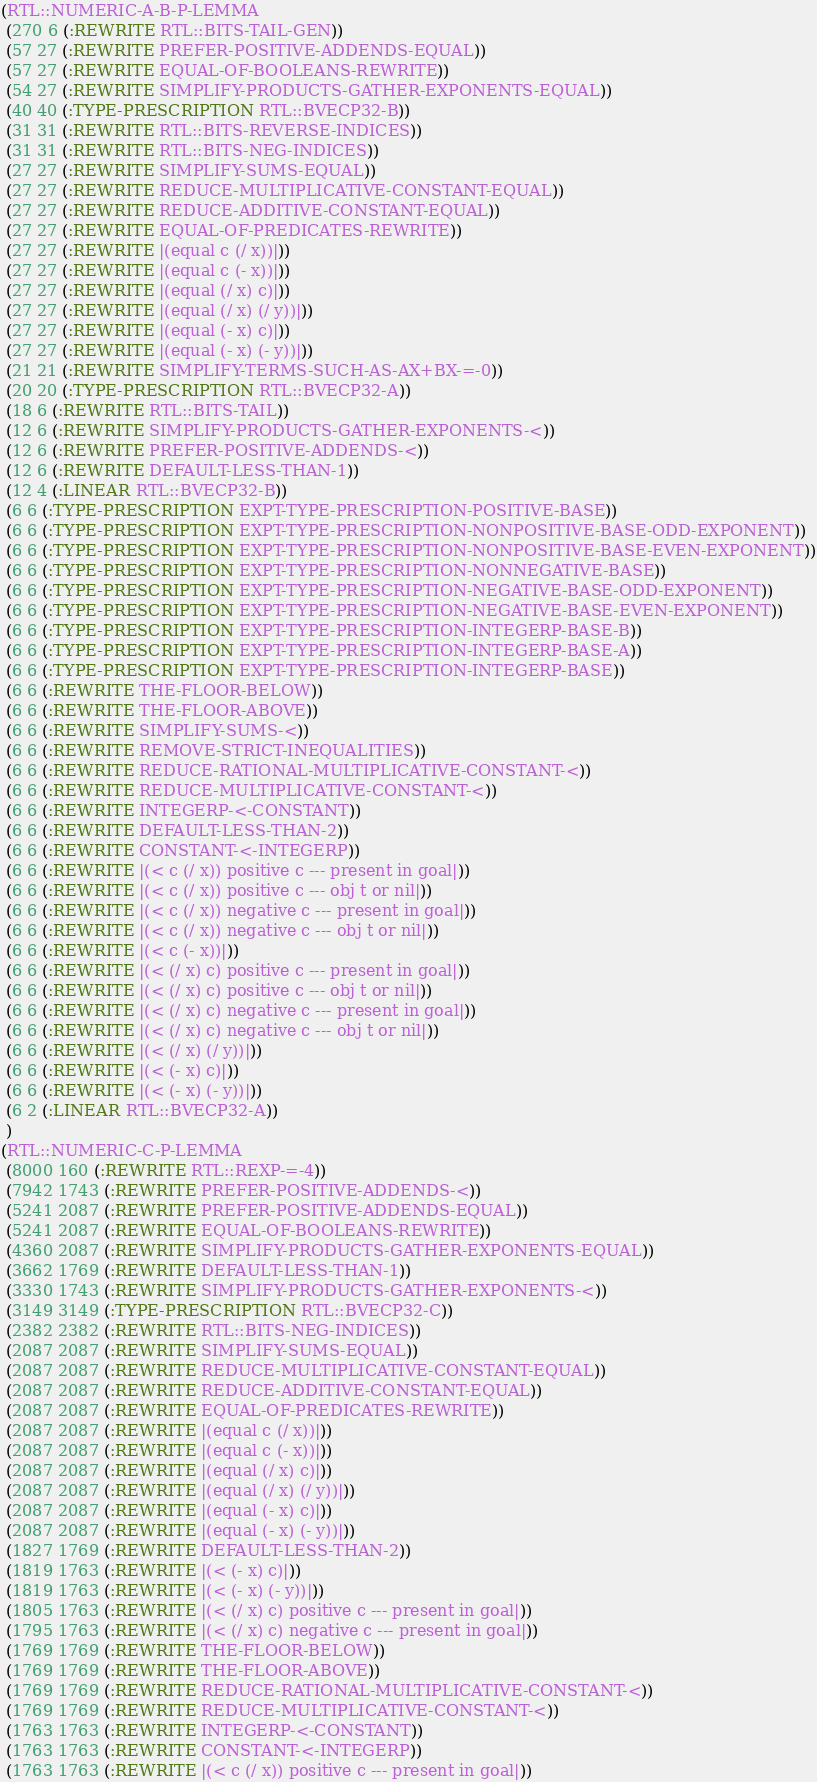Convert code to text. <code><loc_0><loc_0><loc_500><loc_500><_Lisp_>(RTL::NUMERIC-A-B-P-LEMMA
 (270 6 (:REWRITE RTL::BITS-TAIL-GEN))
 (57 27 (:REWRITE PREFER-POSITIVE-ADDENDS-EQUAL))
 (57 27 (:REWRITE EQUAL-OF-BOOLEANS-REWRITE))
 (54 27 (:REWRITE SIMPLIFY-PRODUCTS-GATHER-EXPONENTS-EQUAL))
 (40 40 (:TYPE-PRESCRIPTION RTL::BVECP32-B))
 (31 31 (:REWRITE RTL::BITS-REVERSE-INDICES))
 (31 31 (:REWRITE RTL::BITS-NEG-INDICES))
 (27 27 (:REWRITE SIMPLIFY-SUMS-EQUAL))
 (27 27 (:REWRITE REDUCE-MULTIPLICATIVE-CONSTANT-EQUAL))
 (27 27 (:REWRITE REDUCE-ADDITIVE-CONSTANT-EQUAL))
 (27 27 (:REWRITE EQUAL-OF-PREDICATES-REWRITE))
 (27 27 (:REWRITE |(equal c (/ x))|))
 (27 27 (:REWRITE |(equal c (- x))|))
 (27 27 (:REWRITE |(equal (/ x) c)|))
 (27 27 (:REWRITE |(equal (/ x) (/ y))|))
 (27 27 (:REWRITE |(equal (- x) c)|))
 (27 27 (:REWRITE |(equal (- x) (- y))|))
 (21 21 (:REWRITE SIMPLIFY-TERMS-SUCH-AS-AX+BX-=-0))
 (20 20 (:TYPE-PRESCRIPTION RTL::BVECP32-A))
 (18 6 (:REWRITE RTL::BITS-TAIL))
 (12 6 (:REWRITE SIMPLIFY-PRODUCTS-GATHER-EXPONENTS-<))
 (12 6 (:REWRITE PREFER-POSITIVE-ADDENDS-<))
 (12 6 (:REWRITE DEFAULT-LESS-THAN-1))
 (12 4 (:LINEAR RTL::BVECP32-B))
 (6 6 (:TYPE-PRESCRIPTION EXPT-TYPE-PRESCRIPTION-POSITIVE-BASE))
 (6 6 (:TYPE-PRESCRIPTION EXPT-TYPE-PRESCRIPTION-NONPOSITIVE-BASE-ODD-EXPONENT))
 (6 6 (:TYPE-PRESCRIPTION EXPT-TYPE-PRESCRIPTION-NONPOSITIVE-BASE-EVEN-EXPONENT))
 (6 6 (:TYPE-PRESCRIPTION EXPT-TYPE-PRESCRIPTION-NONNEGATIVE-BASE))
 (6 6 (:TYPE-PRESCRIPTION EXPT-TYPE-PRESCRIPTION-NEGATIVE-BASE-ODD-EXPONENT))
 (6 6 (:TYPE-PRESCRIPTION EXPT-TYPE-PRESCRIPTION-NEGATIVE-BASE-EVEN-EXPONENT))
 (6 6 (:TYPE-PRESCRIPTION EXPT-TYPE-PRESCRIPTION-INTEGERP-BASE-B))
 (6 6 (:TYPE-PRESCRIPTION EXPT-TYPE-PRESCRIPTION-INTEGERP-BASE-A))
 (6 6 (:TYPE-PRESCRIPTION EXPT-TYPE-PRESCRIPTION-INTEGERP-BASE))
 (6 6 (:REWRITE THE-FLOOR-BELOW))
 (6 6 (:REWRITE THE-FLOOR-ABOVE))
 (6 6 (:REWRITE SIMPLIFY-SUMS-<))
 (6 6 (:REWRITE REMOVE-STRICT-INEQUALITIES))
 (6 6 (:REWRITE REDUCE-RATIONAL-MULTIPLICATIVE-CONSTANT-<))
 (6 6 (:REWRITE REDUCE-MULTIPLICATIVE-CONSTANT-<))
 (6 6 (:REWRITE INTEGERP-<-CONSTANT))
 (6 6 (:REWRITE DEFAULT-LESS-THAN-2))
 (6 6 (:REWRITE CONSTANT-<-INTEGERP))
 (6 6 (:REWRITE |(< c (/ x)) positive c --- present in goal|))
 (6 6 (:REWRITE |(< c (/ x)) positive c --- obj t or nil|))
 (6 6 (:REWRITE |(< c (/ x)) negative c --- present in goal|))
 (6 6 (:REWRITE |(< c (/ x)) negative c --- obj t or nil|))
 (6 6 (:REWRITE |(< c (- x))|))
 (6 6 (:REWRITE |(< (/ x) c) positive c --- present in goal|))
 (6 6 (:REWRITE |(< (/ x) c) positive c --- obj t or nil|))
 (6 6 (:REWRITE |(< (/ x) c) negative c --- present in goal|))
 (6 6 (:REWRITE |(< (/ x) c) negative c --- obj t or nil|))
 (6 6 (:REWRITE |(< (/ x) (/ y))|))
 (6 6 (:REWRITE |(< (- x) c)|))
 (6 6 (:REWRITE |(< (- x) (- y))|))
 (6 2 (:LINEAR RTL::BVECP32-A))
 )
(RTL::NUMERIC-C-P-LEMMA
 (8000 160 (:REWRITE RTL::REXP-=-4))
 (7942 1743 (:REWRITE PREFER-POSITIVE-ADDENDS-<))
 (5241 2087 (:REWRITE PREFER-POSITIVE-ADDENDS-EQUAL))
 (5241 2087 (:REWRITE EQUAL-OF-BOOLEANS-REWRITE))
 (4360 2087 (:REWRITE SIMPLIFY-PRODUCTS-GATHER-EXPONENTS-EQUAL))
 (3662 1769 (:REWRITE DEFAULT-LESS-THAN-1))
 (3330 1743 (:REWRITE SIMPLIFY-PRODUCTS-GATHER-EXPONENTS-<))
 (3149 3149 (:TYPE-PRESCRIPTION RTL::BVECP32-C))
 (2382 2382 (:REWRITE RTL::BITS-NEG-INDICES))
 (2087 2087 (:REWRITE SIMPLIFY-SUMS-EQUAL))
 (2087 2087 (:REWRITE REDUCE-MULTIPLICATIVE-CONSTANT-EQUAL))
 (2087 2087 (:REWRITE REDUCE-ADDITIVE-CONSTANT-EQUAL))
 (2087 2087 (:REWRITE EQUAL-OF-PREDICATES-REWRITE))
 (2087 2087 (:REWRITE |(equal c (/ x))|))
 (2087 2087 (:REWRITE |(equal c (- x))|))
 (2087 2087 (:REWRITE |(equal (/ x) c)|))
 (2087 2087 (:REWRITE |(equal (/ x) (/ y))|))
 (2087 2087 (:REWRITE |(equal (- x) c)|))
 (2087 2087 (:REWRITE |(equal (- x) (- y))|))
 (1827 1769 (:REWRITE DEFAULT-LESS-THAN-2))
 (1819 1763 (:REWRITE |(< (- x) c)|))
 (1819 1763 (:REWRITE |(< (- x) (- y))|))
 (1805 1763 (:REWRITE |(< (/ x) c) positive c --- present in goal|))
 (1795 1763 (:REWRITE |(< (/ x) c) negative c --- present in goal|))
 (1769 1769 (:REWRITE THE-FLOOR-BELOW))
 (1769 1769 (:REWRITE THE-FLOOR-ABOVE))
 (1769 1769 (:REWRITE REDUCE-RATIONAL-MULTIPLICATIVE-CONSTANT-<))
 (1769 1769 (:REWRITE REDUCE-MULTIPLICATIVE-CONSTANT-<))
 (1763 1763 (:REWRITE INTEGERP-<-CONSTANT))
 (1763 1763 (:REWRITE CONSTANT-<-INTEGERP))
 (1763 1763 (:REWRITE |(< c (/ x)) positive c --- present in goal|))</code> 